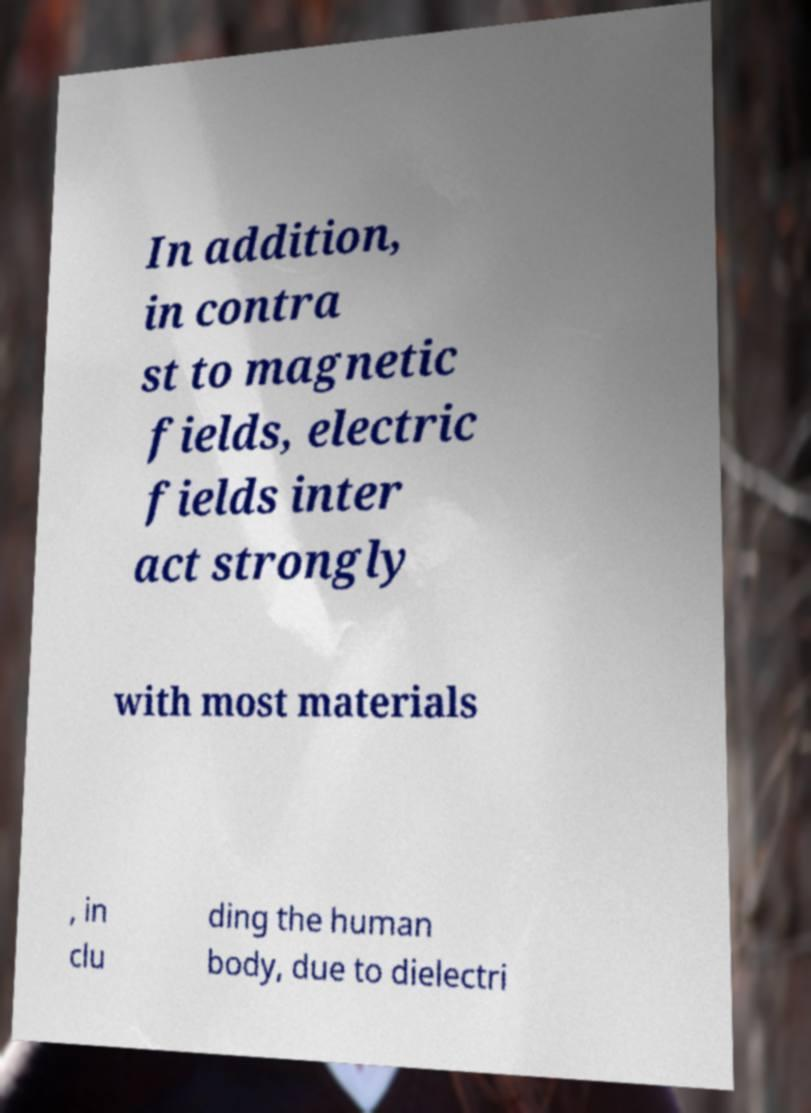Please identify and transcribe the text found in this image. In addition, in contra st to magnetic fields, electric fields inter act strongly with most materials , in clu ding the human body, due to dielectri 